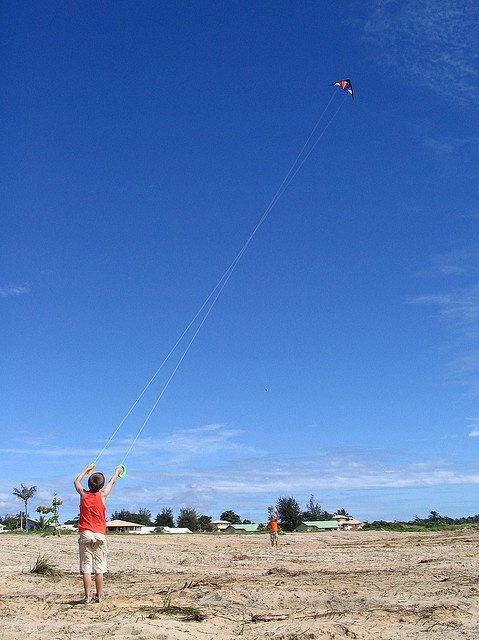Describe the objects in this image and their specific colors. I can see people in darkblue, ivory, salmon, tan, and gray tones, people in darkblue, maroon, gray, and red tones, and kite in darkblue, black, navy, and blue tones in this image. 